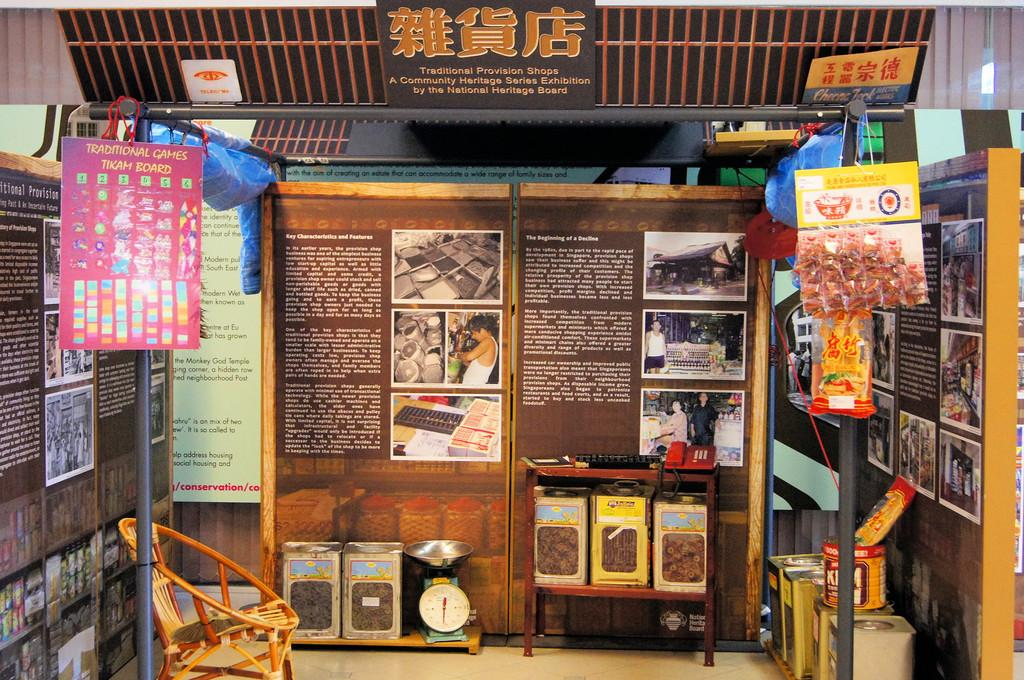<image>
Describe the image concisely. display of products and information about them and a sign above showing it is a traditional provision shops a community heritage series exhibition by the national heritage board 